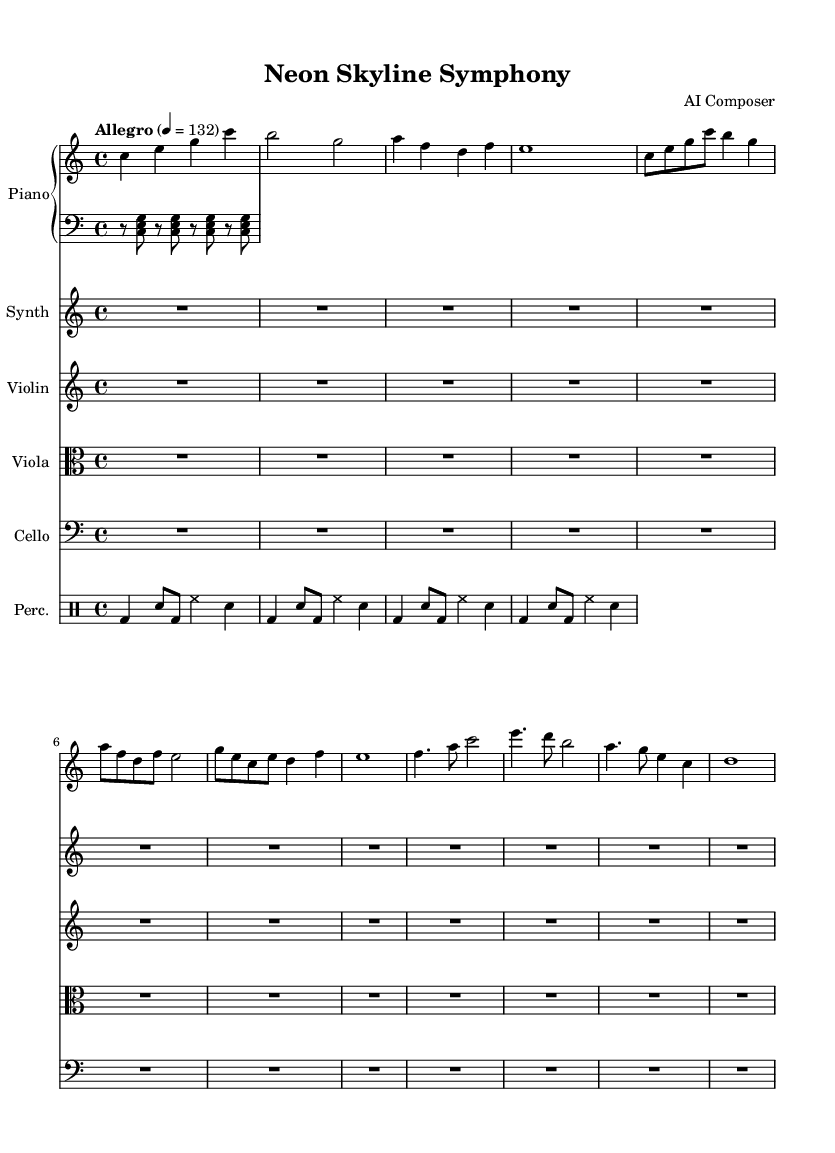What is the key signature of this music? The key signature indicates that there are no sharps or flats, defining it as C major.
Answer: C major What is the time signature of this music? The time signature is indicated by the 4/4 marking, which means there are four beats in each measure and the quarter note gets one beat.
Answer: 4/4 What is the tempo marking for this piece? The tempo marking is set to "Allegro," with a specific tempo of 132 beats per minute, indicating a fast-paced piece.
Answer: Allegro How many measures are present in the piano part? The piano part has 12 measures shown, indicated by the structure of the provided notes and rests in the code.
Answer: 12 Which instrument is listed as the main melodic contributor? The piano is primarily responsible for the melodic lines, as it has defined thematic elements throughout the score.
Answer: Piano How is the rhythmic pattern structured in the percussion part? The percussion part is structured with a consistent alternating pattern of bass drum and snare, creating a driving rhythm typical in contemporary classical compositions.
Answer: Alternating bass drum and snare pattern What style does the piece represent based on its name? The name "Neon Skyline Symphony" suggests a futuristic theme influenced by cityscapes and technology, aligning with contemporary classical aesthetics.
Answer: Futuristic 